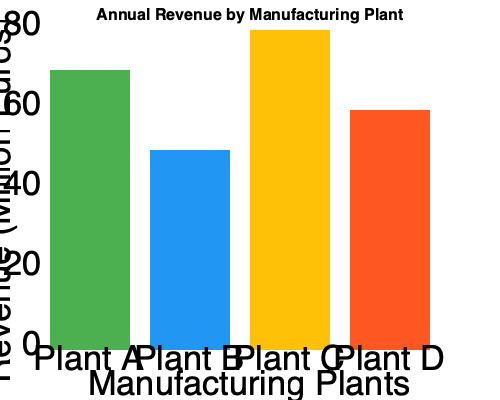Based on the bar graph showing annual revenue for different manufacturing plants, which plant has the highest revenue, and what is the difference in revenue between the highest and lowest performing plants? To answer this question, we need to follow these steps:

1. Identify the highest revenue:
   - Plant A: 70 million euros
   - Plant B: 50 million euros
   - Plant C: 80 million euros
   - Plant D: 60 million euros
   
   Plant C has the highest revenue at 80 million euros.

2. Identify the lowest revenue:
   Plant B has the lowest revenue at 50 million euros.

3. Calculate the difference between the highest and lowest revenues:
   $80 \text{ million} - 50 \text{ million} = 30 \text{ million euros}$

Therefore, Plant C has the highest revenue, and the difference between the highest (Plant C) and lowest (Plant B) performing plants is 30 million euros.
Answer: Plant C; 30 million euros 